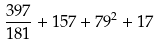Convert formula to latex. <formula><loc_0><loc_0><loc_500><loc_500>\frac { 3 9 7 } { 1 8 1 } + 1 5 7 + 7 9 ^ { 2 } + 1 7</formula> 